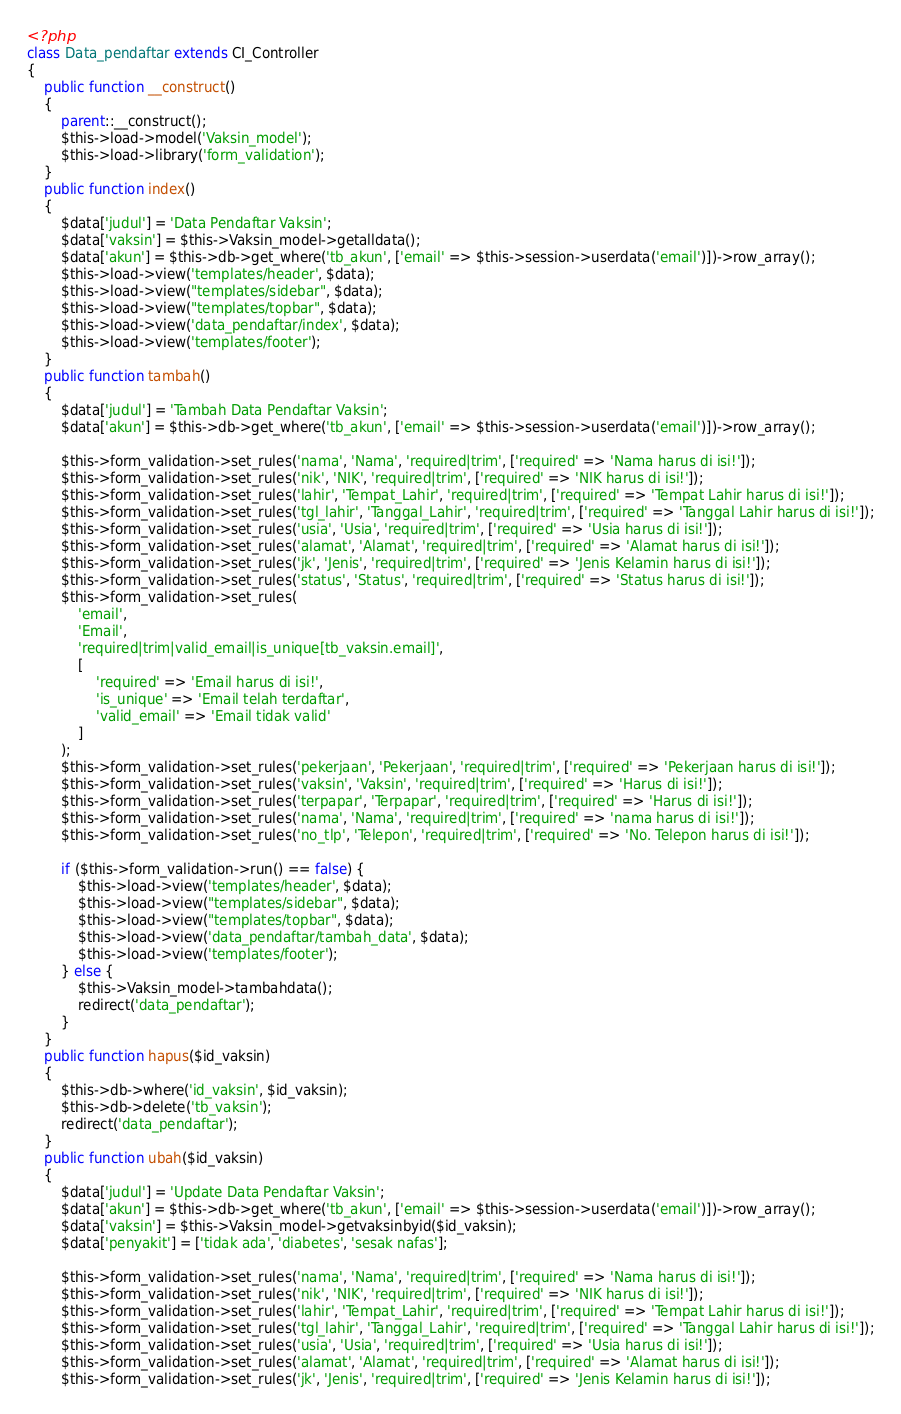Convert code to text. <code><loc_0><loc_0><loc_500><loc_500><_PHP_><?php
class Data_pendaftar extends CI_Controller
{
    public function __construct()
    {
        parent::__construct();
        $this->load->model('Vaksin_model');
        $this->load->library('form_validation');
    }
    public function index()
    {
        $data['judul'] = 'Data Pendaftar Vaksin';
        $data['vaksin'] = $this->Vaksin_model->getalldata();
        $data['akun'] = $this->db->get_where('tb_akun', ['email' => $this->session->userdata('email')])->row_array();
        $this->load->view('templates/header', $data);
        $this->load->view("templates/sidebar", $data);
        $this->load->view("templates/topbar", $data);
        $this->load->view('data_pendaftar/index', $data);
        $this->load->view('templates/footer');
    }
    public function tambah()
    {
        $data['judul'] = 'Tambah Data Pendaftar Vaksin';
        $data['akun'] = $this->db->get_where('tb_akun', ['email' => $this->session->userdata('email')])->row_array();

        $this->form_validation->set_rules('nama', 'Nama', 'required|trim', ['required' => 'Nama harus di isi!']);
        $this->form_validation->set_rules('nik', 'NIK', 'required|trim', ['required' => 'NIK harus di isi!']);
        $this->form_validation->set_rules('lahir', 'Tempat_Lahir', 'required|trim', ['required' => 'Tempat Lahir harus di isi!']);
        $this->form_validation->set_rules('tgl_lahir', 'Tanggal_Lahir', 'required|trim', ['required' => 'Tanggal Lahir harus di isi!']);
        $this->form_validation->set_rules('usia', 'Usia', 'required|trim', ['required' => 'Usia harus di isi!']);
        $this->form_validation->set_rules('alamat', 'Alamat', 'required|trim', ['required' => 'Alamat harus di isi!']);
        $this->form_validation->set_rules('jk', 'Jenis', 'required|trim', ['required' => 'Jenis Kelamin harus di isi!']);
        $this->form_validation->set_rules('status', 'Status', 'required|trim', ['required' => 'Status harus di isi!']);
        $this->form_validation->set_rules(
            'email',
            'Email',
            'required|trim|valid_email|is_unique[tb_vaksin.email]',
            [
                'required' => 'Email harus di isi!',
                'is_unique' => 'Email telah terdaftar',
                'valid_email' => 'Email tidak valid'
            ]
        );
        $this->form_validation->set_rules('pekerjaan', 'Pekerjaan', 'required|trim', ['required' => 'Pekerjaan harus di isi!']);
        $this->form_validation->set_rules('vaksin', 'Vaksin', 'required|trim', ['required' => 'Harus di isi!']);
        $this->form_validation->set_rules('terpapar', 'Terpapar', 'required|trim', ['required' => 'Harus di isi!']);
        $this->form_validation->set_rules('nama', 'Nama', 'required|trim', ['required' => 'nama harus di isi!']);
        $this->form_validation->set_rules('no_tlp', 'Telepon', 'required|trim', ['required' => 'No. Telepon harus di isi!']);

        if ($this->form_validation->run() == false) {
            $this->load->view('templates/header', $data);
            $this->load->view("templates/sidebar", $data);
            $this->load->view("templates/topbar", $data);
            $this->load->view('data_pendaftar/tambah_data', $data);
            $this->load->view('templates/footer');
        } else {
            $this->Vaksin_model->tambahdata();
            redirect('data_pendaftar');
        }
    }
    public function hapus($id_vaksin)
    {
        $this->db->where('id_vaksin', $id_vaksin);
        $this->db->delete('tb_vaksin');
        redirect('data_pendaftar');
    }
    public function ubah($id_vaksin)
    {
        $data['judul'] = 'Update Data Pendaftar Vaksin';
        $data['akun'] = $this->db->get_where('tb_akun', ['email' => $this->session->userdata('email')])->row_array();
        $data['vaksin'] = $this->Vaksin_model->getvaksinbyid($id_vaksin);
        $data['penyakit'] = ['tidak ada', 'diabetes', 'sesak nafas'];

        $this->form_validation->set_rules('nama', 'Nama', 'required|trim', ['required' => 'Nama harus di isi!']);
        $this->form_validation->set_rules('nik', 'NIK', 'required|trim', ['required' => 'NIK harus di isi!']);
        $this->form_validation->set_rules('lahir', 'Tempat_Lahir', 'required|trim', ['required' => 'Tempat Lahir harus di isi!']);
        $this->form_validation->set_rules('tgl_lahir', 'Tanggal_Lahir', 'required|trim', ['required' => 'Tanggal Lahir harus di isi!']);
        $this->form_validation->set_rules('usia', 'Usia', 'required|trim', ['required' => 'Usia harus di isi!']);
        $this->form_validation->set_rules('alamat', 'Alamat', 'required|trim', ['required' => 'Alamat harus di isi!']);
        $this->form_validation->set_rules('jk', 'Jenis', 'required|trim', ['required' => 'Jenis Kelamin harus di isi!']);</code> 